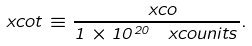<formula> <loc_0><loc_0><loc_500><loc_500>\ x c o t \equiv \frac { \ x c o } { 1 \times 1 0 ^ { 2 0 } \, \ x c o u n i t s } .</formula> 